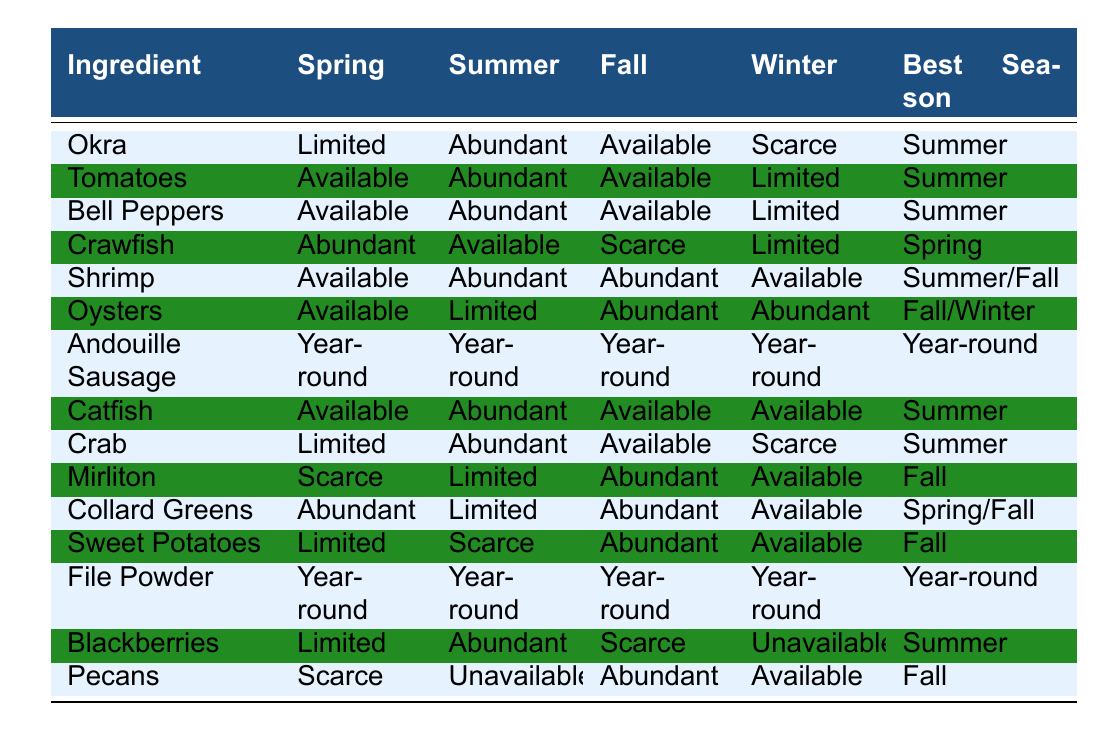What is the best season for Okra? The table shows that the best season for Okra is Summer.
Answer: Summer Is Andouille Sausage available in Winter? Yes, Andouille Sausage is listed as Year-round, meaning it is available in all seasons, including Winter.
Answer: Yes How many ingredients are abundant in Summer? The table shows the ingredients that are Abundant in Summer: Shrimp, Bell Peppers, Catfish, Crab, and Tomatoes. That's a total of 5 ingredients.
Answer: 5 Which ingredient is available in all seasons? The only ingredient listed as Year-round is Andouille Sausage, indicating it is available in all seasons.
Answer: Andouille Sausage What is the seasonal availability of Sweet Potatoes in Spring? According to the table, Sweet Potatoes are Limited in Spring.
Answer: Limited Is there any ingredient that is scarce in Fall? Yes, the table indicates that both Crab and Mirliton are Scarce in Fall.
Answer: Yes What is the best season for Tomatoes, and how does its availability differ in Winter? The best season for Tomatoes is Summer, and during Winter, its availability is Limited.
Answer: Summer; Limited How many ingredients are available in Fall compared to Winter? The ingredients available in Fall are Crawfish, Tomatoes, Bell Peppers, Oysters, Crab, Mirliton, Collard Greens, and Sweet Potatoes (8 total), while in Winter, only Andouille Sausage, Oysters, and Pecans are present (3 total). So, Fall has 5 more ingredients available than Winter.
Answer: Fall has 5 more ingredients available than Winter Is there any ingredient that has the same availability in both Spring and Summer? Yes, Crawfish is Abundant in Spring and Available in Summer, so there are discrepancies, not sameness, but Sweet Potatoes are Limited in Spring and Scarce in Summer.
Answer: No What total number of ingredients is available all year long? According to the table, both Andouille Sausage and File Powder are available Year-round, making a total of 2 ingredients.
Answer: 2 